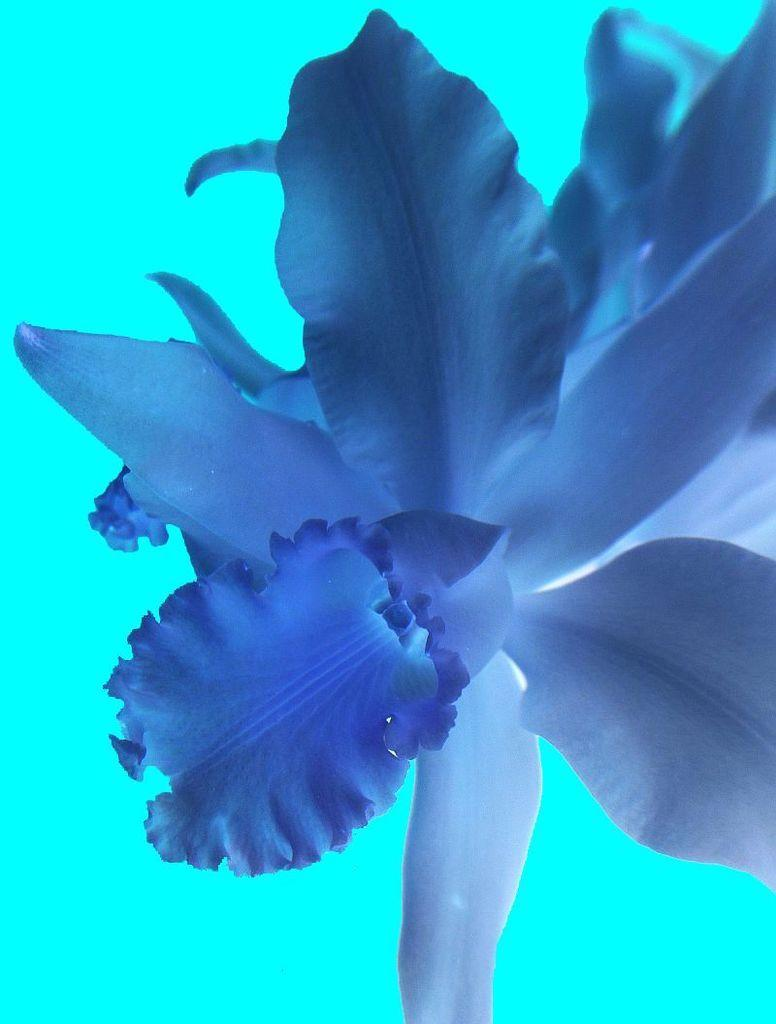What color can be observed in the image? There are objects or elements in the image that have a blue color. What type of pie is being served on the blue plate in the image? There is no pie or blue plate present in the image; the fact only mentions that there are objects or elements with a blue color. 